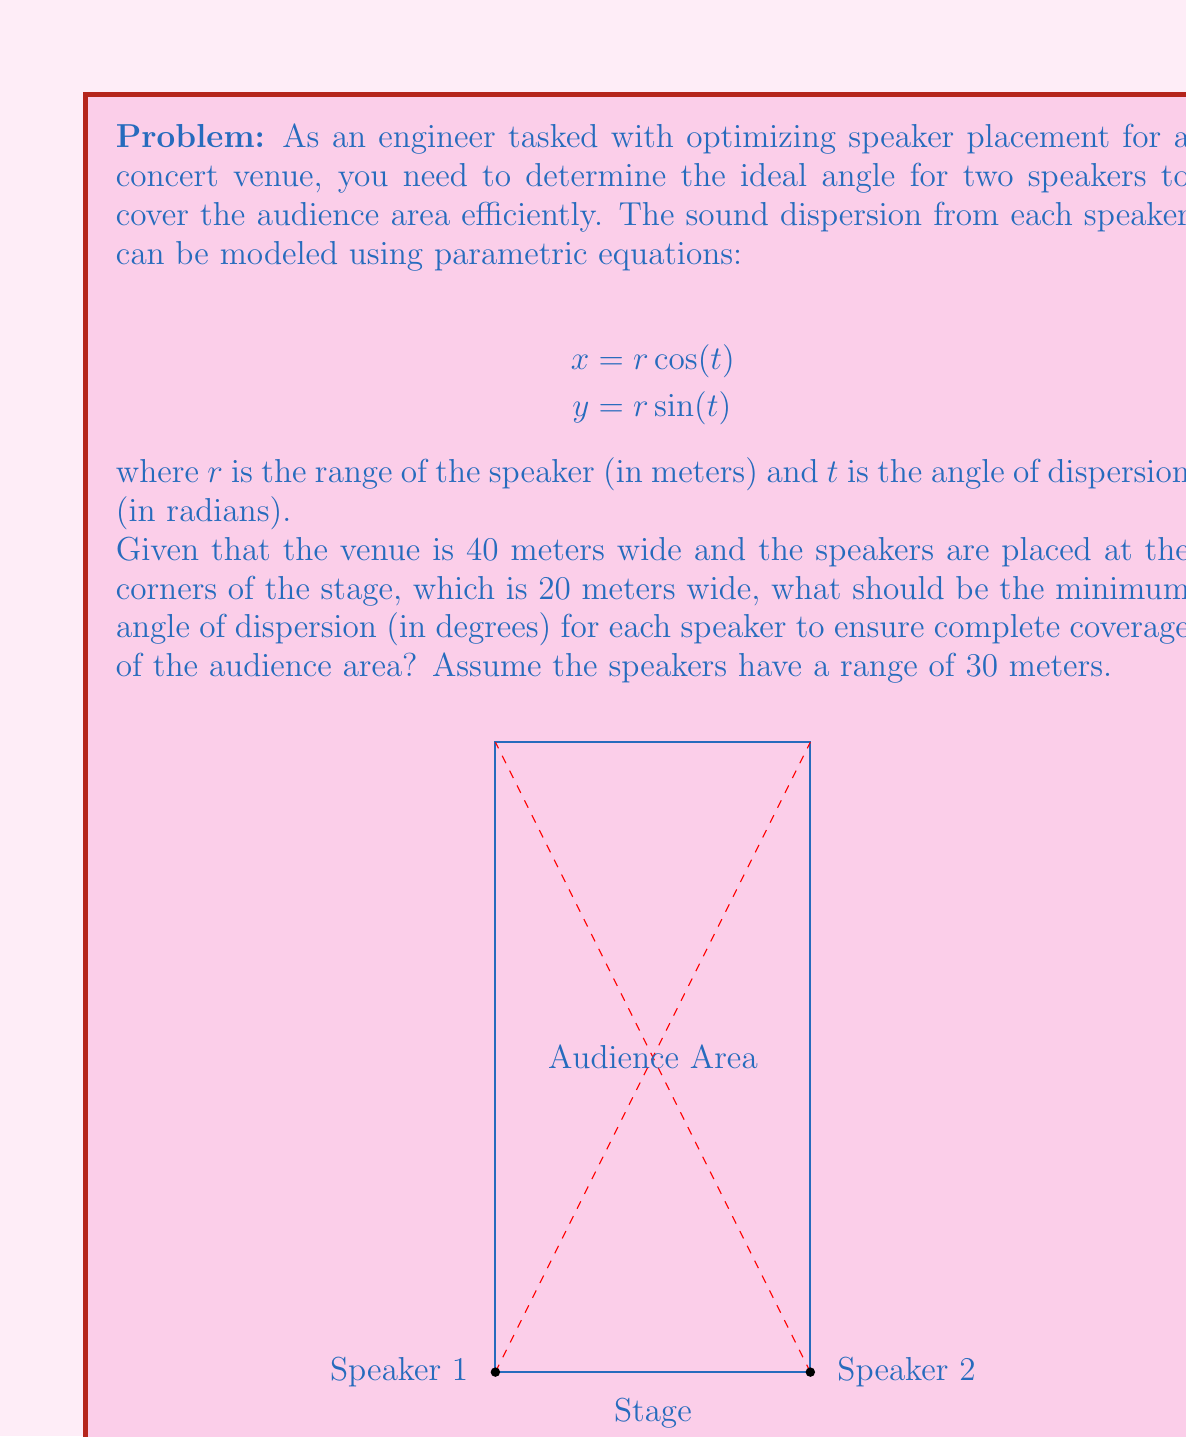Solve this math problem. Let's approach this step-by-step:

1) First, we need to find the angle between the stage and the farthest corner of the audience area. We can do this using the arctangent function:

   $$\theta = \arctan(\frac{40}{20}) = \arctan(2) \approx 1.107 \text{ radians}$$

2) This angle represents half of the total angle we need to cover. So, the total angle of coverage needed is:

   $$2\theta \approx 2.214 \text{ radians}$$

3) Now, we need to check if our speakers can cover this angle given their range. The parametric equations for the sound dispersion are:

   $$x = r \cos(t)$$
   $$y = r \sin(t)$$

4) At the edge of the coverage area, we want:

   $$x = 20$$ (the width of the stage)
   $$y = 40$$ (the depth of the venue)

5) We can use these values in our parametric equations:

   $$20 = 30 \cos(t)$$
   $$40 = 30 \sin(t)$$

6) Dividing these equations:

   $$\frac{20}{40} = \frac{\cos(t)}{\sin(t)} = \cot(t)$$

7) Taking the arctangent of both sides:

   $$t = \arctan(\frac{40}{20}) = \arctan(2) \approx 1.107 \text{ radians}$$

8) This is the same angle we calculated in step 1, which confirms our approach.

9) Convert this angle to degrees:

   $$1.107 \text{ radians} \times \frac{180^{\circ}}{\pi} \approx 63.4^{\circ}$$

Therefore, each speaker needs to have a minimum dispersion angle of approximately 63.4° to cover the entire audience area.
Answer: 63.4° 